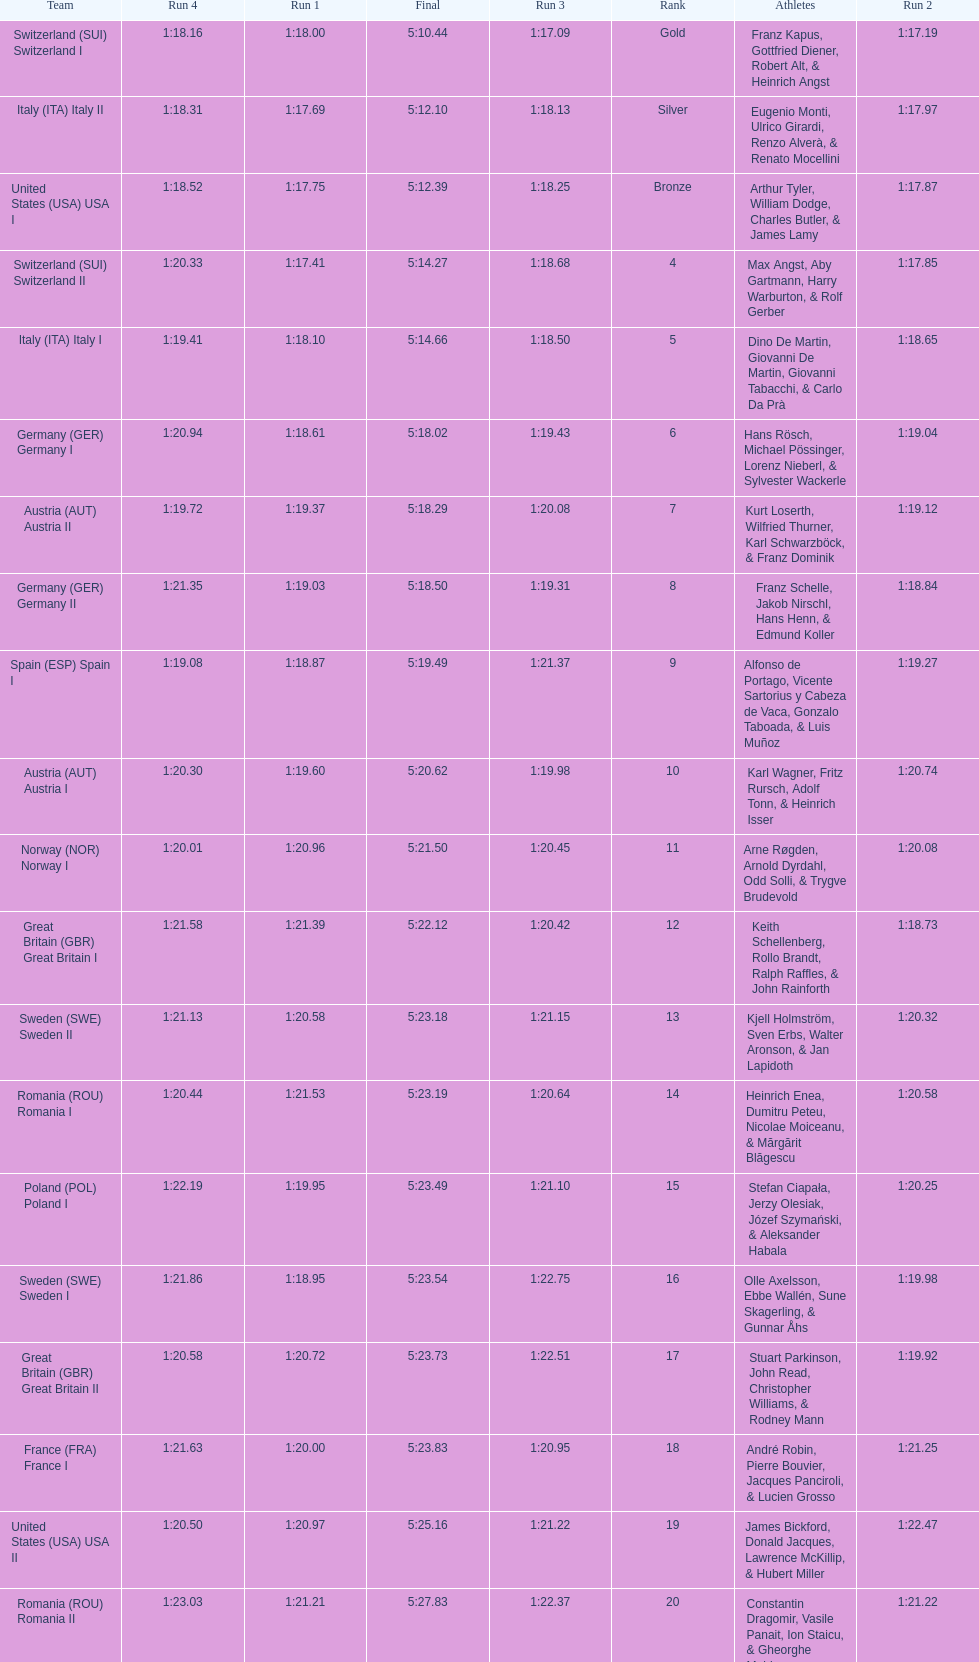Who achieved a greater position, italy or germany? Italy. 